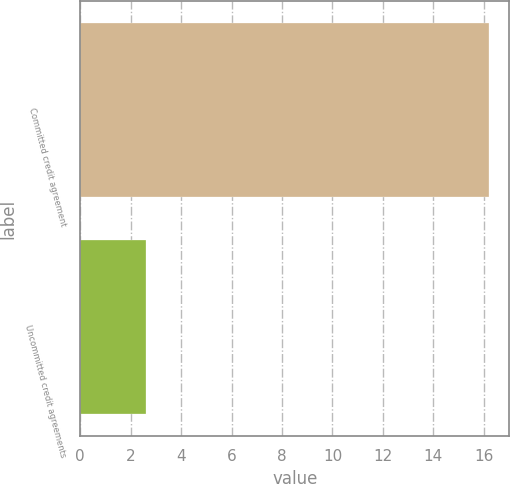Convert chart to OTSL. <chart><loc_0><loc_0><loc_500><loc_500><bar_chart><fcel>Committed credit agreement<fcel>Uncommitted credit agreements<nl><fcel>16.2<fcel>2.6<nl></chart> 